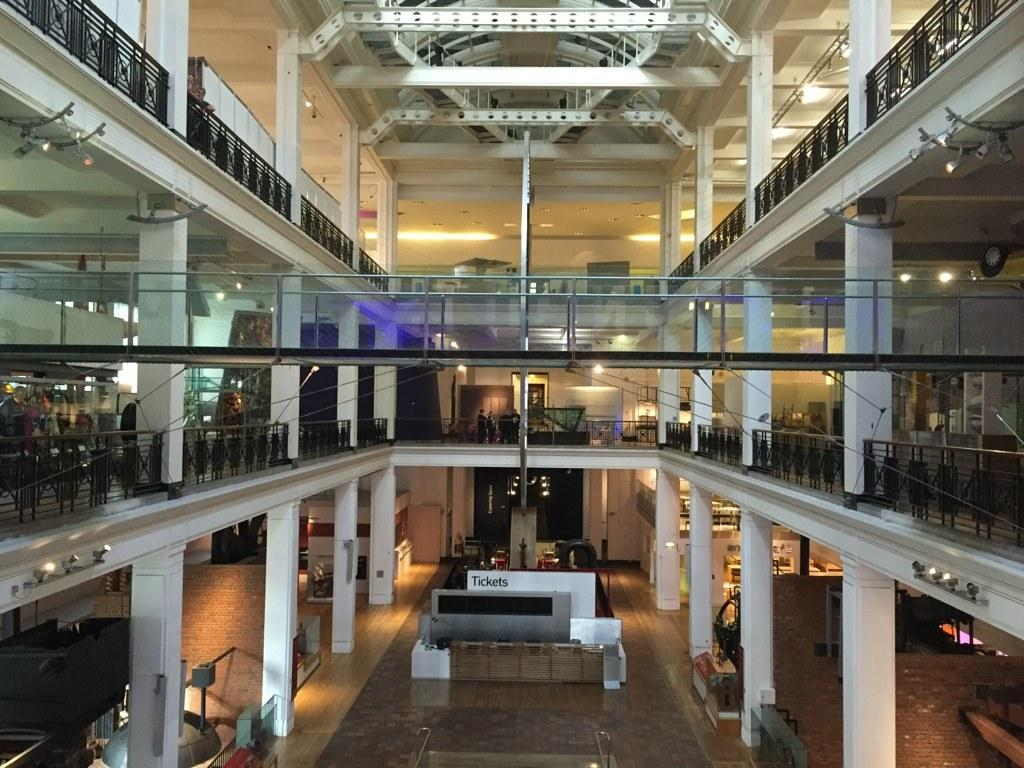What type of location is depicted in the image? The image shows an inside view of a building. What architectural feature can be seen in the image? There is a wall visible in the image. What structural elements support the building? Pillars are present in the image. What is providing illumination in the image? Lights are visible in the image. Are there any people present in the image? Yes, there are people in the image. What objects can be seen in the image? There are some objects in the image. Are the people in the image engaged in a fight? There is no indication of a fight in the image; the people are simply present in the building. What type of mask is being worn by the person in the image? There is no person wearing a mask in the image. 